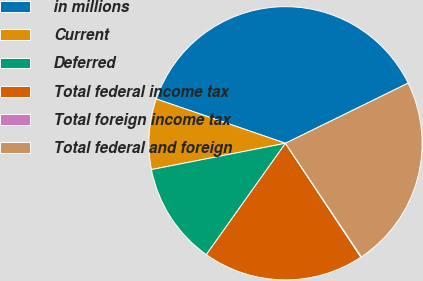Convert chart to OTSL. <chart><loc_0><loc_0><loc_500><loc_500><pie_chart><fcel>in millions<fcel>Current<fcel>Deferred<fcel>Total federal income tax<fcel>Total foreign income tax<fcel>Total federal and foreign<nl><fcel>37.48%<fcel>8.34%<fcel>12.08%<fcel>19.14%<fcel>0.07%<fcel>22.88%<nl></chart> 